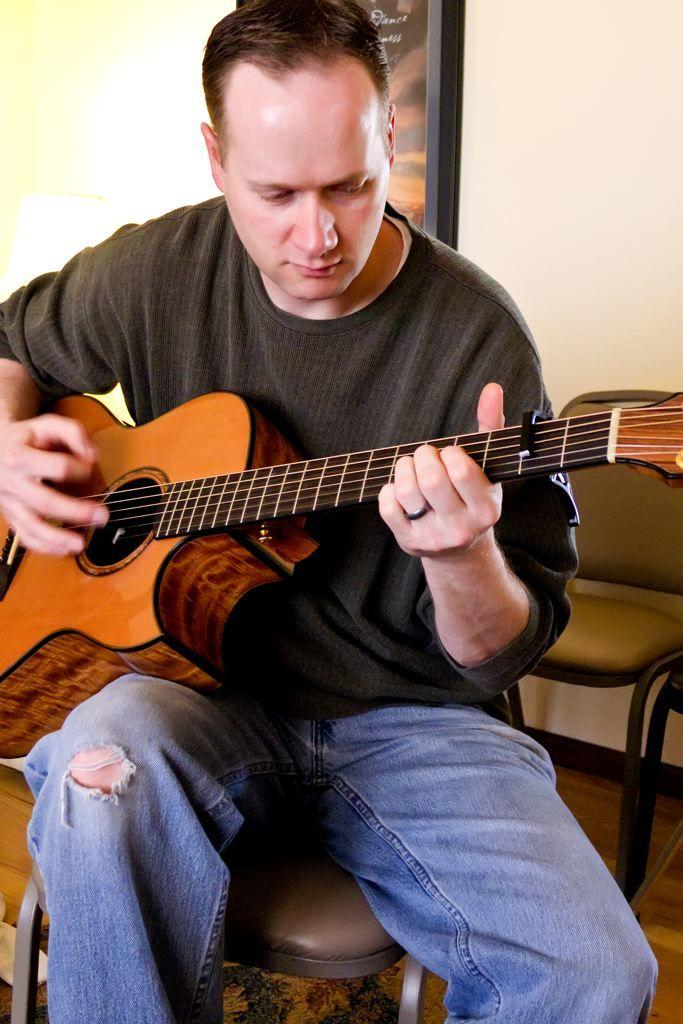Who is the main subject in the image? There is a man in the image. What is the man doing in the image? The man is sitting on a chair and playing the guitar. What is the man holding in his hand? The man is holding a guitar in his hand. What can be seen in the background of the image? There is a wall with a frame in the background of the image. What type of current is flowing through the guitar in the image? There is no indication of any electrical current in the image, as the guitar is being played acoustically. What organization is responsible for the man's guitar playing in the image? There is no organization mentioned or implied in the image, and the man's guitar playing is a personal activity. 